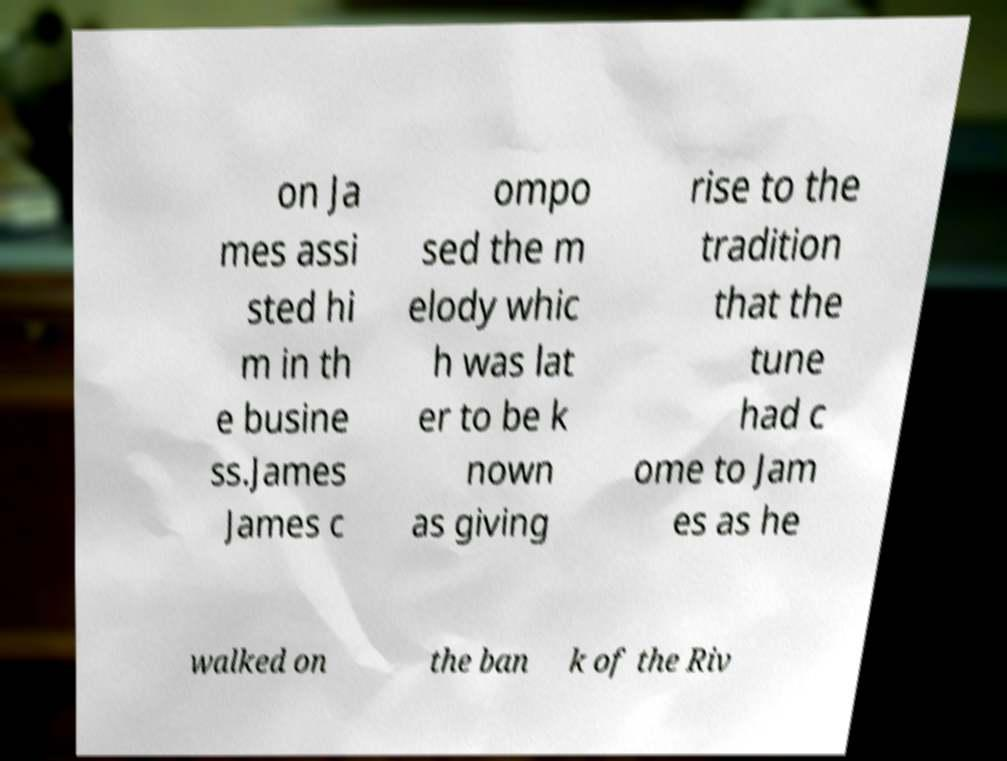Could you extract and type out the text from this image? on Ja mes assi sted hi m in th e busine ss.James James c ompo sed the m elody whic h was lat er to be k nown as giving rise to the tradition that the tune had c ome to Jam es as he walked on the ban k of the Riv 